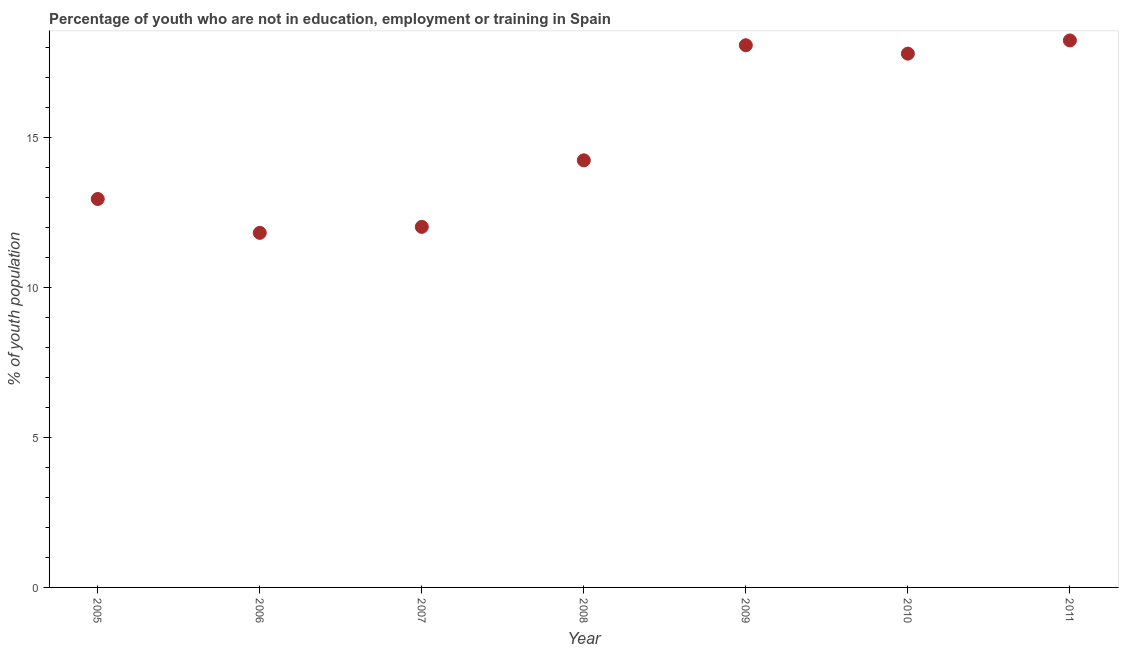What is the unemployed youth population in 2008?
Provide a short and direct response. 14.25. Across all years, what is the maximum unemployed youth population?
Keep it short and to the point. 18.25. Across all years, what is the minimum unemployed youth population?
Provide a short and direct response. 11.83. In which year was the unemployed youth population maximum?
Provide a succinct answer. 2011. What is the sum of the unemployed youth population?
Offer a terse response. 105.22. What is the difference between the unemployed youth population in 2005 and 2007?
Your answer should be compact. 0.93. What is the average unemployed youth population per year?
Offer a very short reply. 15.03. What is the median unemployed youth population?
Give a very brief answer. 14.25. Do a majority of the years between 2005 and 2008 (inclusive) have unemployed youth population greater than 9 %?
Make the answer very short. Yes. What is the ratio of the unemployed youth population in 2007 to that in 2008?
Provide a short and direct response. 0.84. Is the unemployed youth population in 2008 less than that in 2010?
Your answer should be very brief. Yes. What is the difference between the highest and the second highest unemployed youth population?
Your answer should be very brief. 0.16. What is the difference between the highest and the lowest unemployed youth population?
Make the answer very short. 6.42. How many years are there in the graph?
Your answer should be compact. 7. Does the graph contain grids?
Your response must be concise. No. What is the title of the graph?
Your response must be concise. Percentage of youth who are not in education, employment or training in Spain. What is the label or title of the X-axis?
Ensure brevity in your answer.  Year. What is the label or title of the Y-axis?
Provide a succinct answer. % of youth population. What is the % of youth population in 2005?
Make the answer very short. 12.96. What is the % of youth population in 2006?
Provide a short and direct response. 11.83. What is the % of youth population in 2007?
Make the answer very short. 12.03. What is the % of youth population in 2008?
Keep it short and to the point. 14.25. What is the % of youth population in 2009?
Offer a very short reply. 18.09. What is the % of youth population in 2010?
Your answer should be compact. 17.81. What is the % of youth population in 2011?
Ensure brevity in your answer.  18.25. What is the difference between the % of youth population in 2005 and 2006?
Keep it short and to the point. 1.13. What is the difference between the % of youth population in 2005 and 2007?
Offer a terse response. 0.93. What is the difference between the % of youth population in 2005 and 2008?
Offer a very short reply. -1.29. What is the difference between the % of youth population in 2005 and 2009?
Provide a short and direct response. -5.13. What is the difference between the % of youth population in 2005 and 2010?
Ensure brevity in your answer.  -4.85. What is the difference between the % of youth population in 2005 and 2011?
Your answer should be compact. -5.29. What is the difference between the % of youth population in 2006 and 2007?
Give a very brief answer. -0.2. What is the difference between the % of youth population in 2006 and 2008?
Your answer should be compact. -2.42. What is the difference between the % of youth population in 2006 and 2009?
Ensure brevity in your answer.  -6.26. What is the difference between the % of youth population in 2006 and 2010?
Make the answer very short. -5.98. What is the difference between the % of youth population in 2006 and 2011?
Make the answer very short. -6.42. What is the difference between the % of youth population in 2007 and 2008?
Make the answer very short. -2.22. What is the difference between the % of youth population in 2007 and 2009?
Offer a terse response. -6.06. What is the difference between the % of youth population in 2007 and 2010?
Give a very brief answer. -5.78. What is the difference between the % of youth population in 2007 and 2011?
Make the answer very short. -6.22. What is the difference between the % of youth population in 2008 and 2009?
Your answer should be compact. -3.84. What is the difference between the % of youth population in 2008 and 2010?
Offer a terse response. -3.56. What is the difference between the % of youth population in 2008 and 2011?
Keep it short and to the point. -4. What is the difference between the % of youth population in 2009 and 2010?
Your answer should be very brief. 0.28. What is the difference between the % of youth population in 2009 and 2011?
Your answer should be compact. -0.16. What is the difference between the % of youth population in 2010 and 2011?
Your response must be concise. -0.44. What is the ratio of the % of youth population in 2005 to that in 2006?
Keep it short and to the point. 1.1. What is the ratio of the % of youth population in 2005 to that in 2007?
Offer a terse response. 1.08. What is the ratio of the % of youth population in 2005 to that in 2008?
Your answer should be very brief. 0.91. What is the ratio of the % of youth population in 2005 to that in 2009?
Make the answer very short. 0.72. What is the ratio of the % of youth population in 2005 to that in 2010?
Provide a short and direct response. 0.73. What is the ratio of the % of youth population in 2005 to that in 2011?
Make the answer very short. 0.71. What is the ratio of the % of youth population in 2006 to that in 2007?
Keep it short and to the point. 0.98. What is the ratio of the % of youth population in 2006 to that in 2008?
Keep it short and to the point. 0.83. What is the ratio of the % of youth population in 2006 to that in 2009?
Ensure brevity in your answer.  0.65. What is the ratio of the % of youth population in 2006 to that in 2010?
Provide a short and direct response. 0.66. What is the ratio of the % of youth population in 2006 to that in 2011?
Provide a short and direct response. 0.65. What is the ratio of the % of youth population in 2007 to that in 2008?
Keep it short and to the point. 0.84. What is the ratio of the % of youth population in 2007 to that in 2009?
Give a very brief answer. 0.67. What is the ratio of the % of youth population in 2007 to that in 2010?
Give a very brief answer. 0.68. What is the ratio of the % of youth population in 2007 to that in 2011?
Offer a very short reply. 0.66. What is the ratio of the % of youth population in 2008 to that in 2009?
Give a very brief answer. 0.79. What is the ratio of the % of youth population in 2008 to that in 2010?
Offer a terse response. 0.8. What is the ratio of the % of youth population in 2008 to that in 2011?
Give a very brief answer. 0.78. What is the ratio of the % of youth population in 2009 to that in 2010?
Give a very brief answer. 1.02. What is the ratio of the % of youth population in 2009 to that in 2011?
Provide a short and direct response. 0.99. 